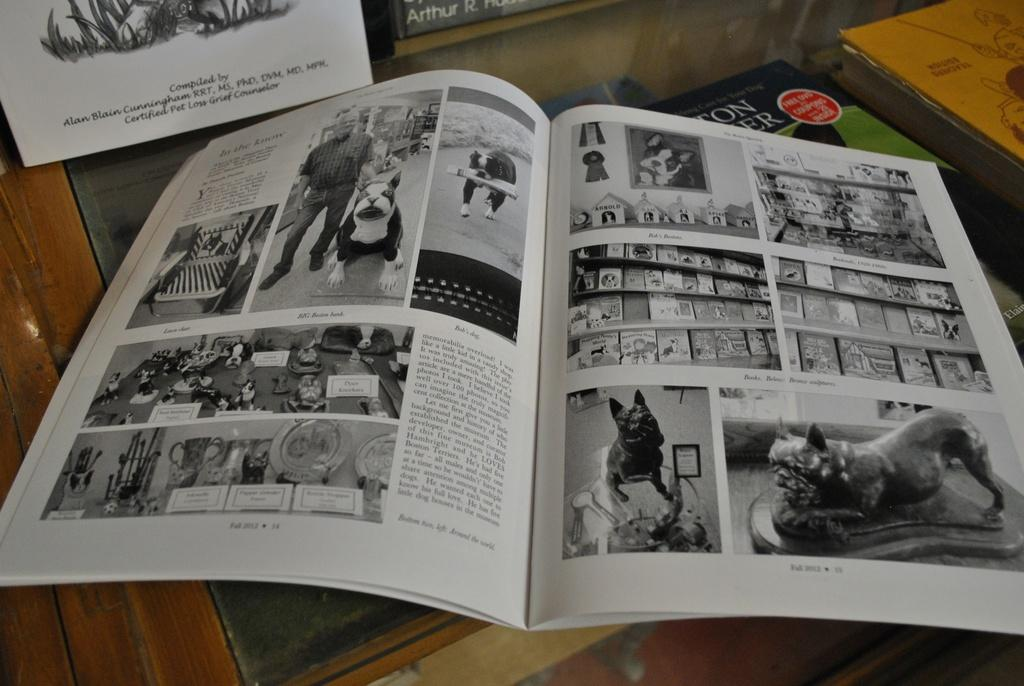<image>
Relay a brief, clear account of the picture shown. Open magazine that says the page35 on the bottom. 